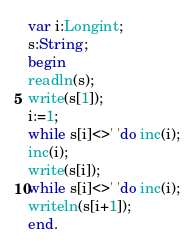Convert code to text. <code><loc_0><loc_0><loc_500><loc_500><_Pascal_>var i:Longint;
s:String;
begin
readln(s);
write(s[1]);
i:=1;
while s[i]<>' 'do inc(i);
inc(i);
write(s[i]);
while s[i]<>' 'do inc(i);
writeln(s[i+1]);
end.</code> 